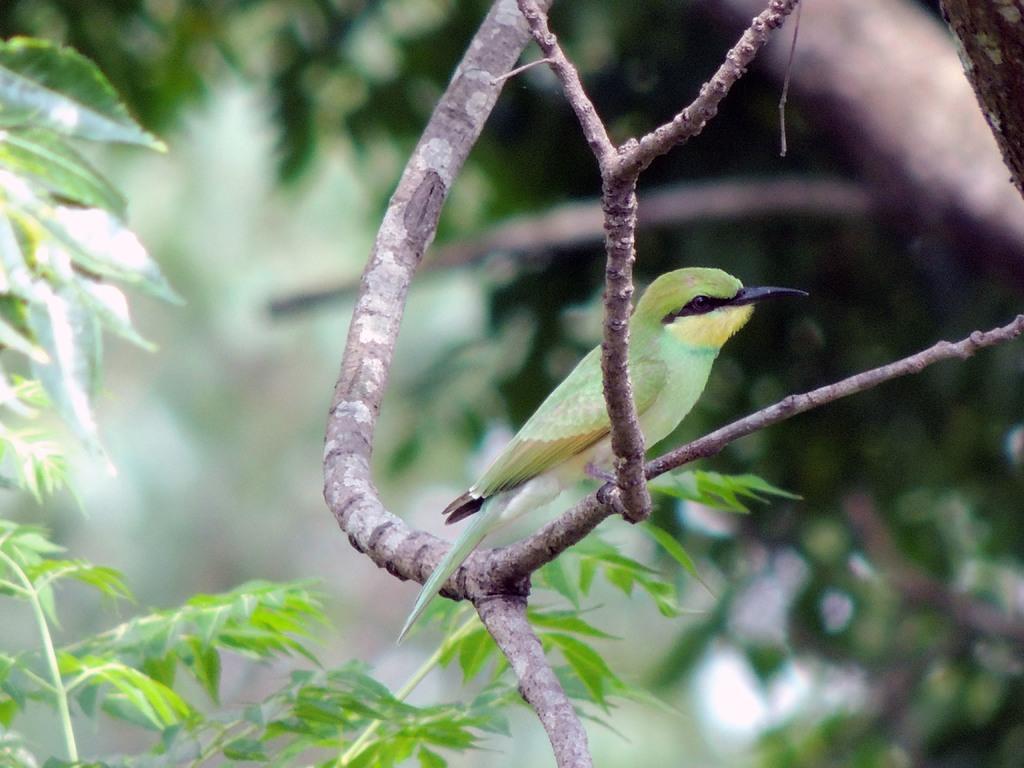Describe this image in one or two sentences. In the middle I can see a bird is sitting on the branch of a tree. In the background, I can see trees. This image is taken may be in the forest. 